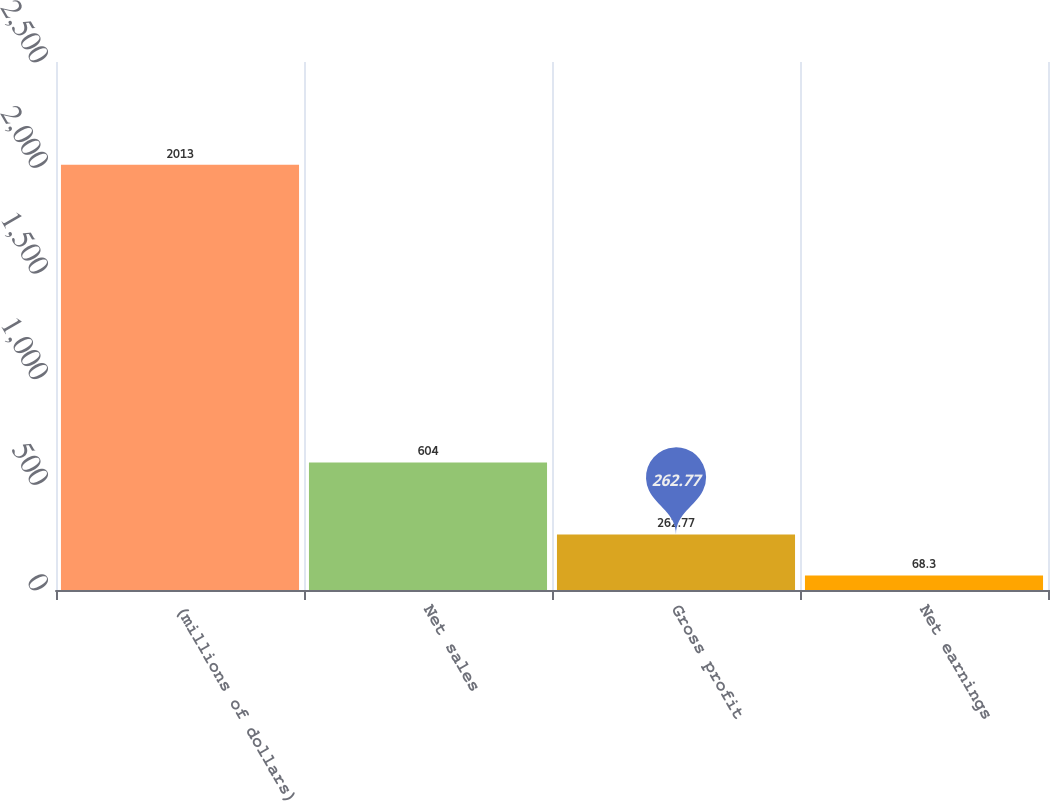Convert chart. <chart><loc_0><loc_0><loc_500><loc_500><bar_chart><fcel>(millions of dollars)<fcel>Net sales<fcel>Gross profit<fcel>Net earnings<nl><fcel>2013<fcel>604<fcel>262.77<fcel>68.3<nl></chart> 